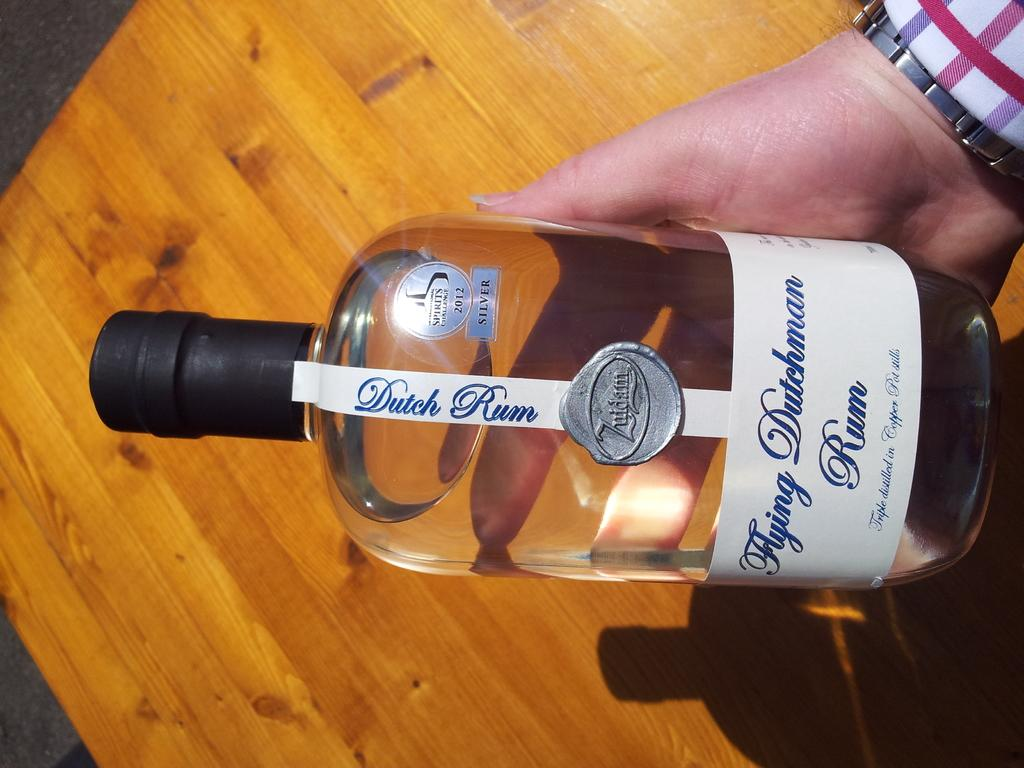<image>
Write a terse but informative summary of the picture. A person hold an alcohol bottle in their hands with the label dutch rum. 